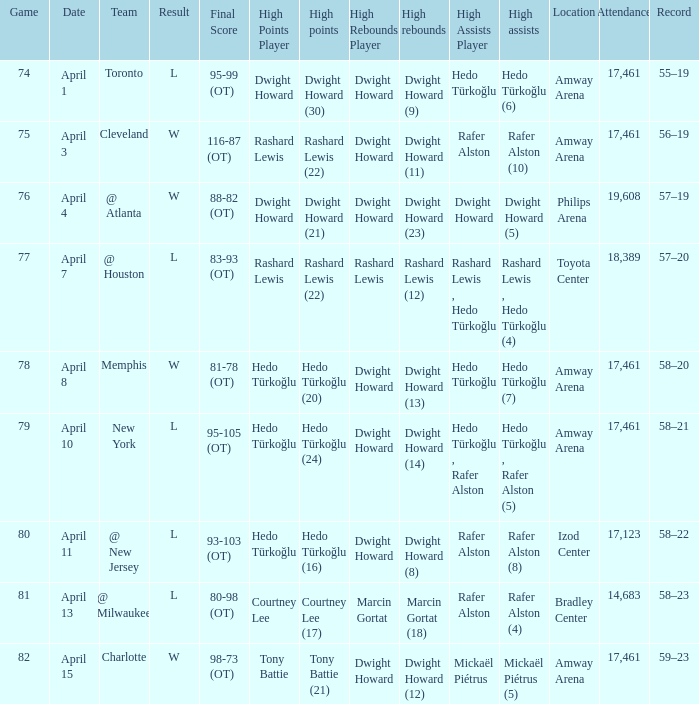What is the highest rebounds for game 81? Marcin Gortat (18). 